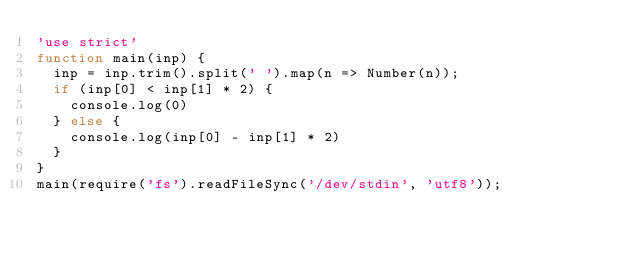Convert code to text. <code><loc_0><loc_0><loc_500><loc_500><_JavaScript_>'use strict'
function main(inp) {
  inp = inp.trim().split(' ').map(n => Number(n));
  if (inp[0] < inp[1] * 2) {
    console.log(0)
  } else {
    console.log(inp[0] - inp[1] * 2)
  }
}
main(require('fs').readFileSync('/dev/stdin', 'utf8'));
</code> 